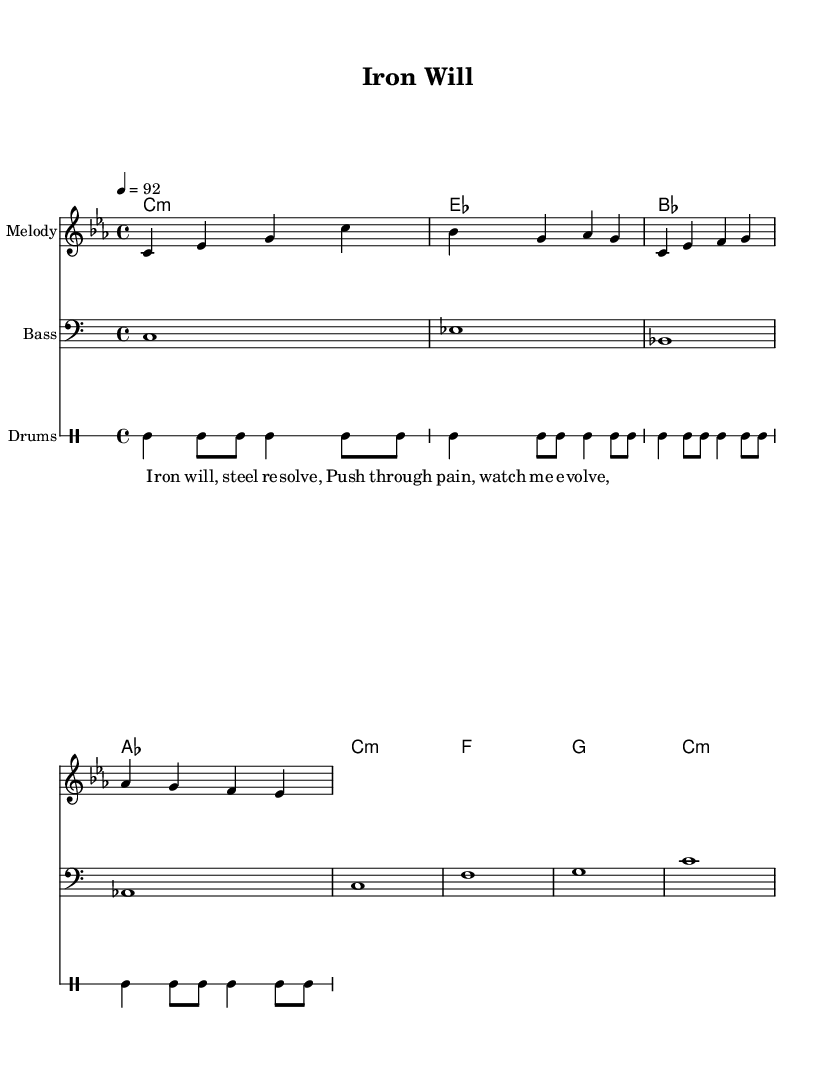What is the key signature of this music? The key signature is C minor, which is indicated by three flats (B flat, E flat, A flat) in the beginning of the staff.
Answer: C minor What is the time signature of this music? The time signature is indicated as 4/4, showing that there are four beats in each measure and the quarter note gets one beat.
Answer: 4/4 What is the tempo marking of this piece? The tempo marking is 4 = 92, which means there are 92 beats per minute at a moderate pace.
Answer: 92 How many measures are in the melody? The melody contains a total of four measures, which can be counted by looking at the bar lines on the staff.
Answer: 4 What instruments are featured in this score? The score includes a melody staff, bass staff, and a drum staff, suggesting the presence of melody, bass line, and percussion.
Answer: Melody, Bass, Drums What is the first lyric in this piece? The first lyric is "Iron will," which is found at the beginning of the lyrics section beneath the melody notes.
Answer: Iron will How many unique chords are played throughout the harmony section? There are four unique chords played: C minor, E flat major, B flat major, and A flat major, identifiable by the chord symbols above the staff.
Answer: 4 